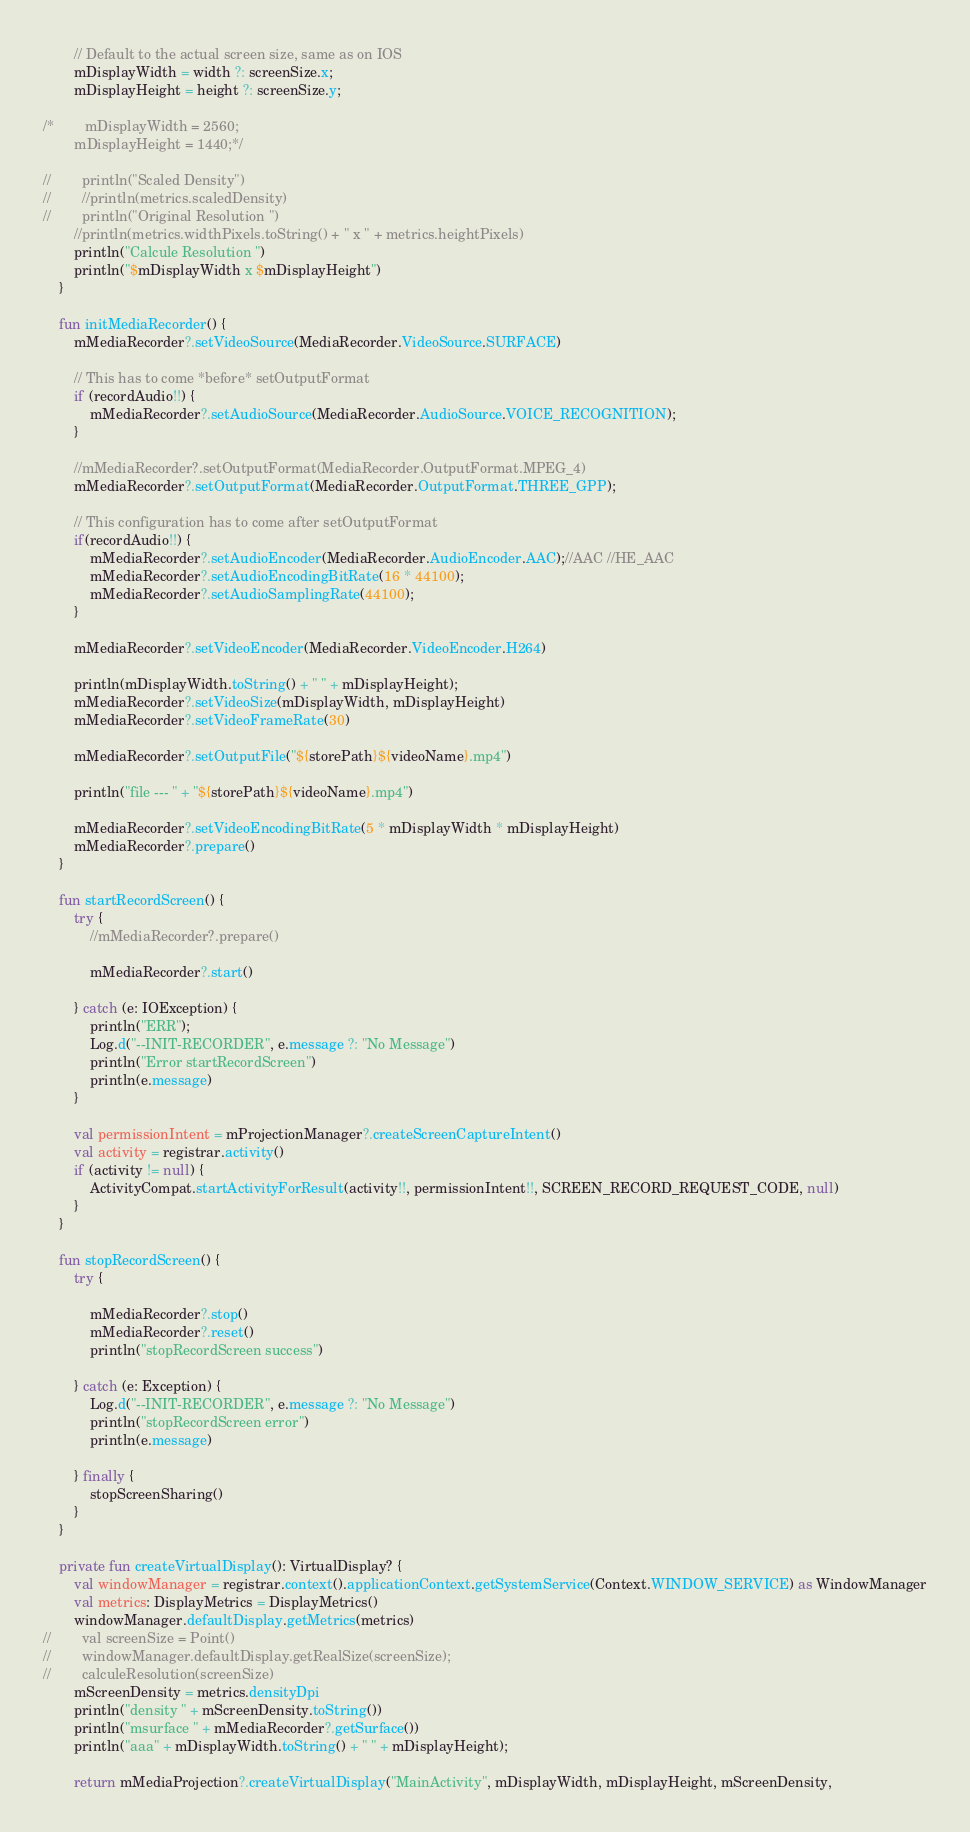Convert code to text. <code><loc_0><loc_0><loc_500><loc_500><_Kotlin_>
        // Default to the actual screen size, same as on IOS
        mDisplayWidth = width ?: screenSize.x;
        mDisplayHeight = height ?: screenSize.y;

/*        mDisplayWidth = 2560;
        mDisplayHeight = 1440;*/

//        println("Scaled Density")
//        //println(metrics.scaledDensity)
//        println("Original Resolution ")
        //println(metrics.widthPixels.toString() + " x " + metrics.heightPixels)
        println("Calcule Resolution ")
        println("$mDisplayWidth x $mDisplayHeight")
    }

    fun initMediaRecorder() {
        mMediaRecorder?.setVideoSource(MediaRecorder.VideoSource.SURFACE)

        // This has to come *before* setOutputFormat
        if (recordAudio!!) {
            mMediaRecorder?.setAudioSource(MediaRecorder.AudioSource.VOICE_RECOGNITION);
        }

        //mMediaRecorder?.setOutputFormat(MediaRecorder.OutputFormat.MPEG_4)
        mMediaRecorder?.setOutputFormat(MediaRecorder.OutputFormat.THREE_GPP);

        // This configuration has to come after setOutputFormat
        if(recordAudio!!) {
            mMediaRecorder?.setAudioEncoder(MediaRecorder.AudioEncoder.AAC);//AAC //HE_AAC
            mMediaRecorder?.setAudioEncodingBitRate(16 * 44100);
            mMediaRecorder?.setAudioSamplingRate(44100);
        }

        mMediaRecorder?.setVideoEncoder(MediaRecorder.VideoEncoder.H264)

        println(mDisplayWidth.toString() + " " + mDisplayHeight);
        mMediaRecorder?.setVideoSize(mDisplayWidth, mDisplayHeight)
        mMediaRecorder?.setVideoFrameRate(30)

        mMediaRecorder?.setOutputFile("${storePath}${videoName}.mp4")

        println("file --- " + "${storePath}${videoName}.mp4")

        mMediaRecorder?.setVideoEncodingBitRate(5 * mDisplayWidth * mDisplayHeight)
        mMediaRecorder?.prepare()
    }

    fun startRecordScreen() {
        try {
            //mMediaRecorder?.prepare()

            mMediaRecorder?.start()

        } catch (e: IOException) {
            println("ERR");
            Log.d("--INIT-RECORDER", e.message ?: "No Message")
            println("Error startRecordScreen")
            println(e.message)
        }

        val permissionIntent = mProjectionManager?.createScreenCaptureIntent()
        val activity = registrar.activity()
        if (activity != null) {
            ActivityCompat.startActivityForResult(activity!!, permissionIntent!!, SCREEN_RECORD_REQUEST_CODE, null)
        }
    }

    fun stopRecordScreen() {
        try {

            mMediaRecorder?.stop()
            mMediaRecorder?.reset()
            println("stopRecordScreen success")

        } catch (e: Exception) {
            Log.d("--INIT-RECORDER", e.message ?: "No Message")
            println("stopRecordScreen error")
            println(e.message)

        } finally {
            stopScreenSharing()
        }
    }

    private fun createVirtualDisplay(): VirtualDisplay? {
        val windowManager = registrar.context().applicationContext.getSystemService(Context.WINDOW_SERVICE) as WindowManager
        val metrics: DisplayMetrics = DisplayMetrics()
        windowManager.defaultDisplay.getMetrics(metrics)
//        val screenSize = Point()
//        windowManager.defaultDisplay.getRealSize(screenSize);
//        calculeResolution(screenSize)
        mScreenDensity = metrics.densityDpi
        println("density " + mScreenDensity.toString())
        println("msurface " + mMediaRecorder?.getSurface())
        println("aaa" + mDisplayWidth.toString() + " " + mDisplayHeight);

        return mMediaProjection?.createVirtualDisplay("MainActivity", mDisplayWidth, mDisplayHeight, mScreenDensity,</code> 